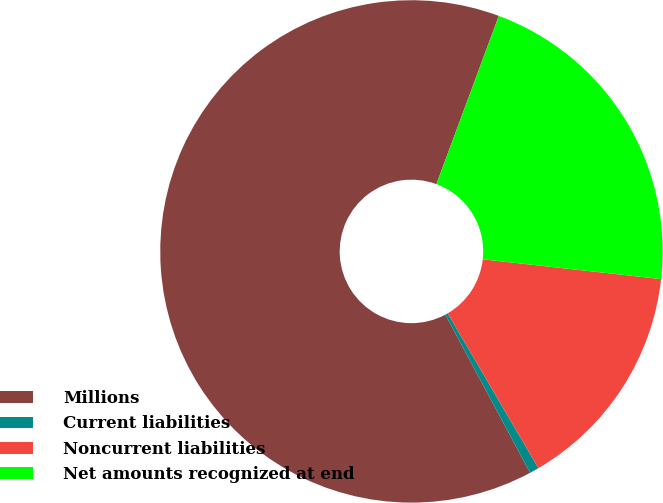Convert chart. <chart><loc_0><loc_0><loc_500><loc_500><pie_chart><fcel>Millions<fcel>Current liabilities<fcel>Noncurrent liabilities<fcel>Net amounts recognized at end<nl><fcel>63.48%<fcel>0.6%<fcel>14.81%<fcel>21.1%<nl></chart> 